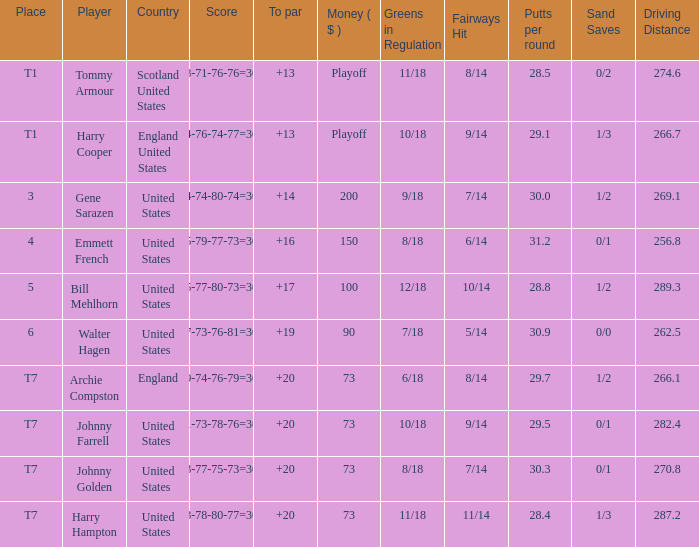What is the ranking when Archie Compston is the player and the money is $73? T7. 